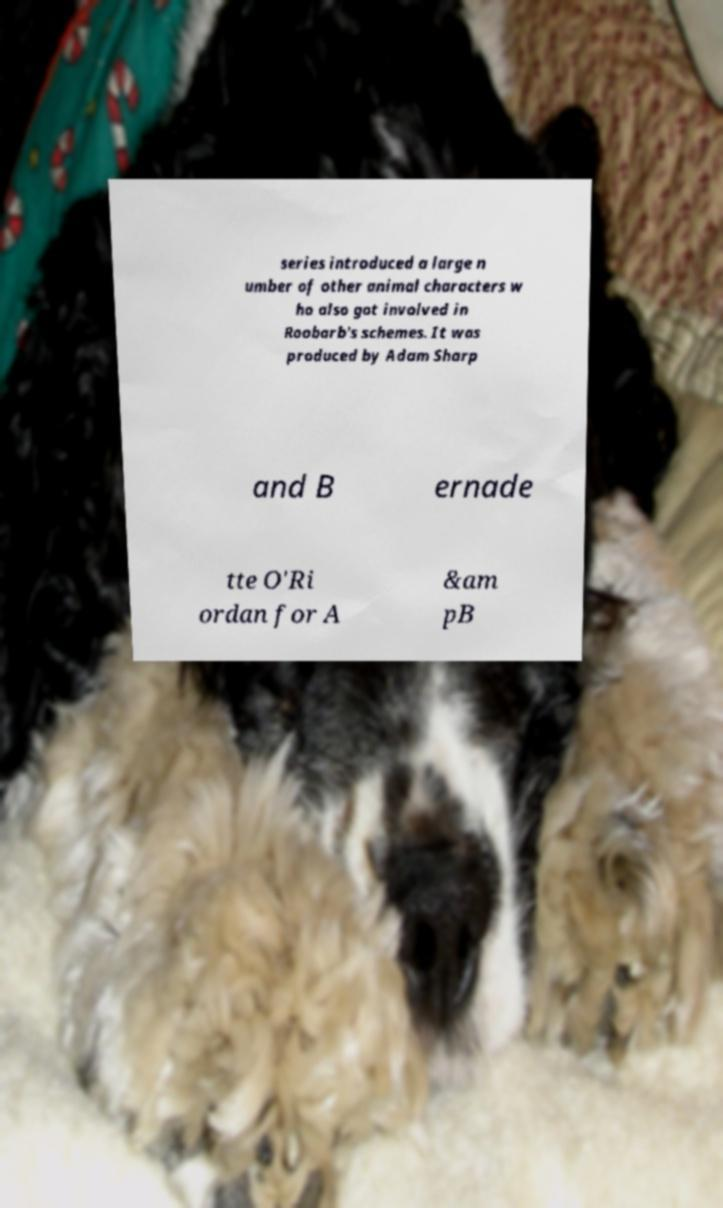I need the written content from this picture converted into text. Can you do that? series introduced a large n umber of other animal characters w ho also got involved in Roobarb's schemes. It was produced by Adam Sharp and B ernade tte O'Ri ordan for A &am pB 